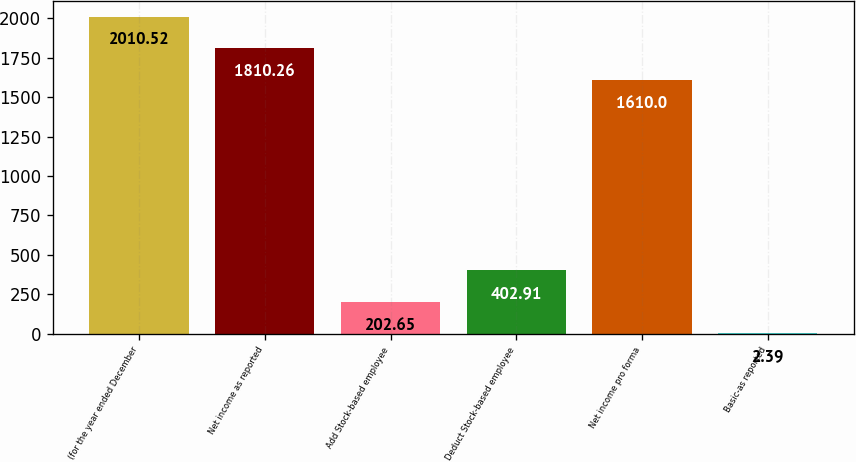<chart> <loc_0><loc_0><loc_500><loc_500><bar_chart><fcel>(for the year ended December<fcel>Net income as reported<fcel>Add Stock-based employee<fcel>Deduct Stock-based employee<fcel>Net income pro forma<fcel>Basic-as reported<nl><fcel>2010.52<fcel>1810.26<fcel>202.65<fcel>402.91<fcel>1610<fcel>2.39<nl></chart> 